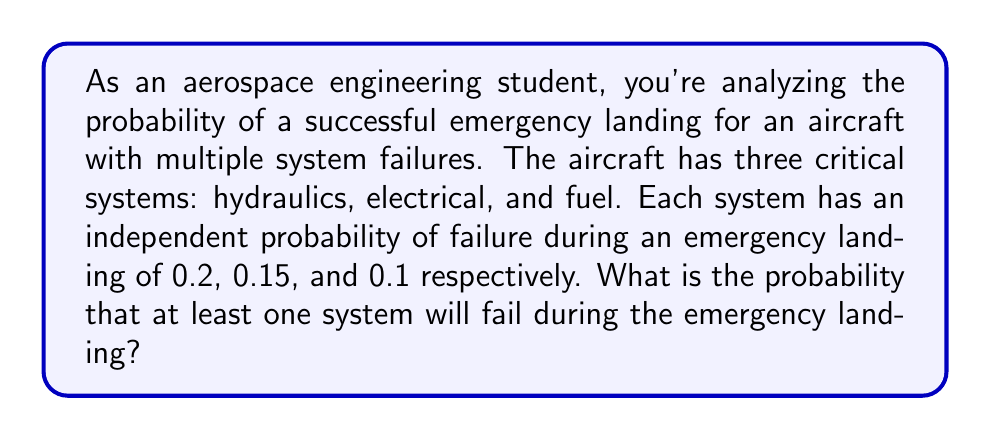Solve this math problem. Let's approach this step-by-step:

1) First, we need to understand that we're looking for the probability of at least one system failing. This is easier to calculate by finding the probability of no systems failing and then subtracting that from 1.

2) Let's define our events:
   H: Hydraulic system fails (P(H) = 0.2)
   E: Electrical system fails (P(E) = 0.15)
   F: Fuel system fails (P(F) = 0.1)

3) The probability of each system not failing is:
   P(not H) = 1 - 0.2 = 0.8
   P(not E) = 1 - 0.15 = 0.85
   P(not F) = 1 - 0.1 = 0.9

4) Since the failures are independent, the probability of all systems not failing is the product of their individual probabilities of not failing:

   P(no failures) = P(not H) × P(not E) × P(not F)
                  = 0.8 × 0.85 × 0.9
                  = 0.612

5) Therefore, the probability of at least one system failing is:

   P(at least one failure) = 1 - P(no failures)
                           = 1 - 0.612
                           = 0.388

6) We can express this as a percentage:
   0.388 × 100% = 38.8%
Answer: 38.8% 